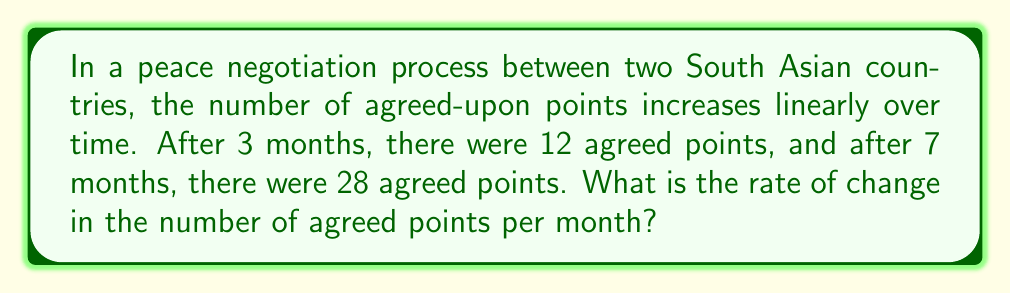Provide a solution to this math problem. To solve this problem, we need to calculate the rate of change, which is the slope of the line representing the relationship between time and agreed points.

Step 1: Identify the two points on the line.
Point 1: (3 months, 12 points)
Point 2: (7 months, 28 points)

Step 2: Use the slope formula to calculate the rate of change.
The slope formula is:
$$ m = \frac{y_2 - y_1}{x_2 - x_1} $$
Where $(x_1, y_1)$ is the first point and $(x_2, y_2)$ is the second point.

Step 3: Plug in the values.
$$ m = \frac{28 - 12}{7 - 3} = \frac{16}{4} $$

Step 4: Simplify the fraction.
$$ m = 4 $$

Therefore, the rate of change is 4 agreed points per month.
Answer: 4 points/month 